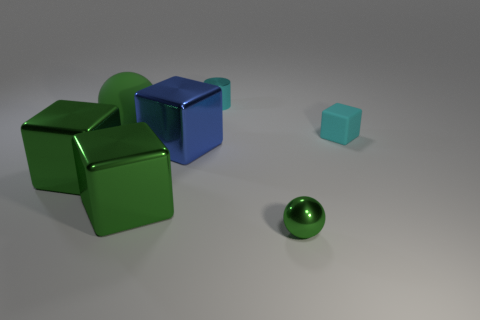There is another matte object that is the same shape as the big blue thing; what size is it?
Your response must be concise. Small. What number of cylinders are cyan shiny objects or rubber objects?
Your answer should be compact. 1. What number of large blue cubes are to the right of the tiny cyan thing on the left side of the small shiny thing on the right side of the tiny cyan metallic object?
Give a very brief answer. 0. What is the size of the metallic object that is the same color as the tiny block?
Make the answer very short. Small. Is there a small ball made of the same material as the tiny cyan block?
Offer a very short reply. No. Does the big green ball have the same material as the tiny cube?
Keep it short and to the point. Yes. There is a big blue shiny thing that is to the left of the cyan cube; how many things are behind it?
Your answer should be compact. 3. What number of cyan things are balls or tiny metallic balls?
Keep it short and to the point. 0. There is a large green thing behind the green shiny thing that is on the left side of the sphere behind the cyan matte block; what is its shape?
Provide a succinct answer. Sphere. There is a ball that is the same size as the cyan rubber cube; what color is it?
Make the answer very short. Green. 